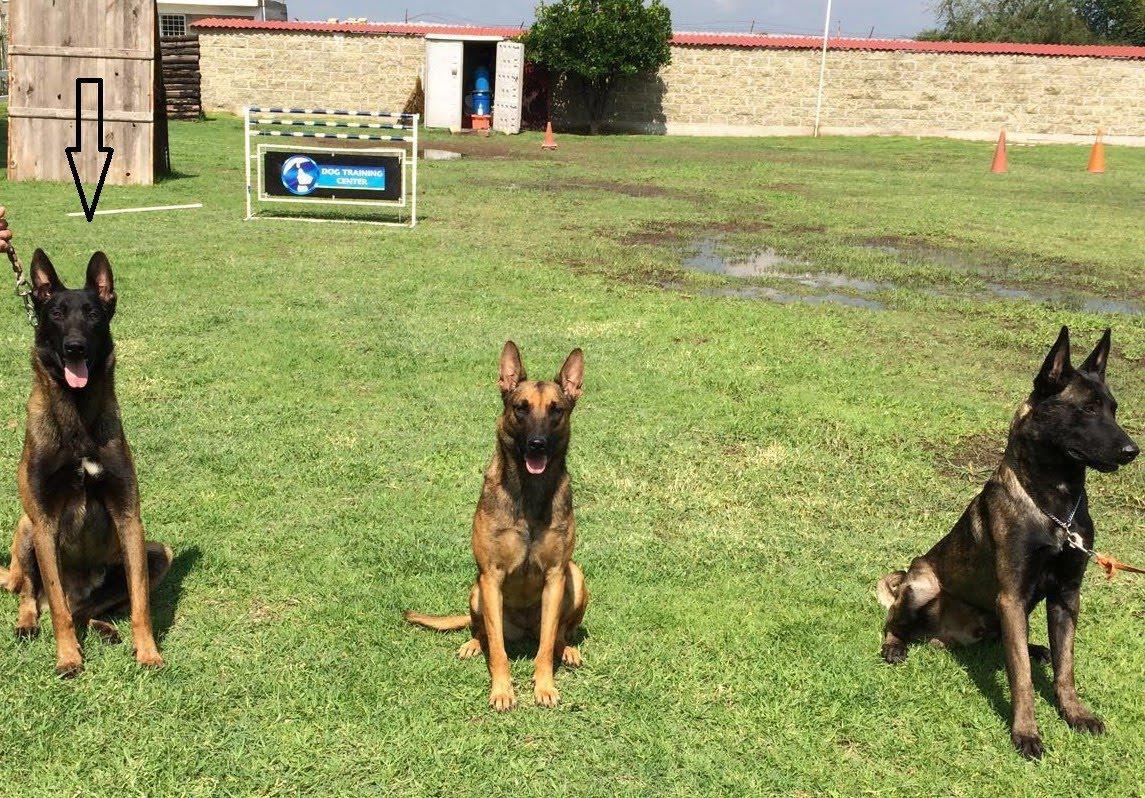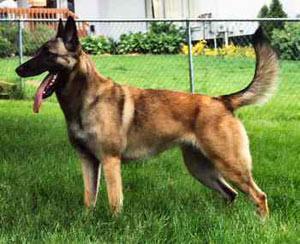The first image is the image on the left, the second image is the image on the right. Considering the images on both sides, is "Three german shepherd dogs sit upright in a row on grass in one image." valid? Answer yes or no. Yes. The first image is the image on the left, the second image is the image on the right. Evaluate the accuracy of this statement regarding the images: "The right image contains exactly three dogs.". Is it true? Answer yes or no. No. 